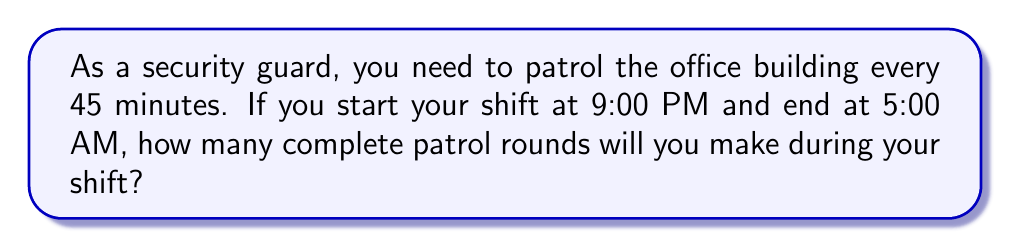Provide a solution to this math problem. Let's approach this step-by-step:

1. First, calculate the total duration of the shift:
   From 9:00 PM to 5:00 AM = 8 hours

2. Convert 8 hours to minutes:
   $8 \times 60 = 480$ minutes

3. Each patrol round takes 45 minutes. To find the number of complete rounds, we need to divide the total shift time by the time for each round:

   $\text{Number of rounds} = \frac{\text{Total shift time}}{\text{Time per round}} = \frac{480}{45}$

4. Perform the division:
   $\frac{480}{45} = 10.67$

5. Since we can only complete whole rounds, we need to round down to the nearest integer.

Therefore, you will complete 10 full patrol rounds during your shift.
Answer: 10 rounds 